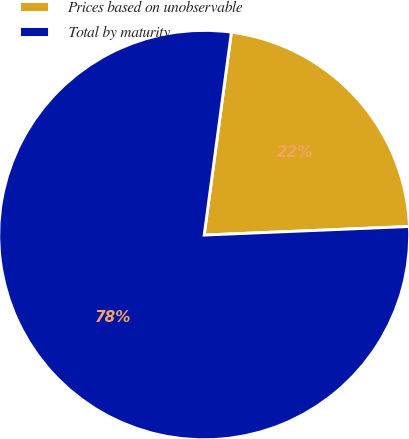Convert chart to OTSL. <chart><loc_0><loc_0><loc_500><loc_500><pie_chart><fcel>Prices based on unobservable<fcel>Total by maturity<nl><fcel>22.22%<fcel>77.78%<nl></chart> 